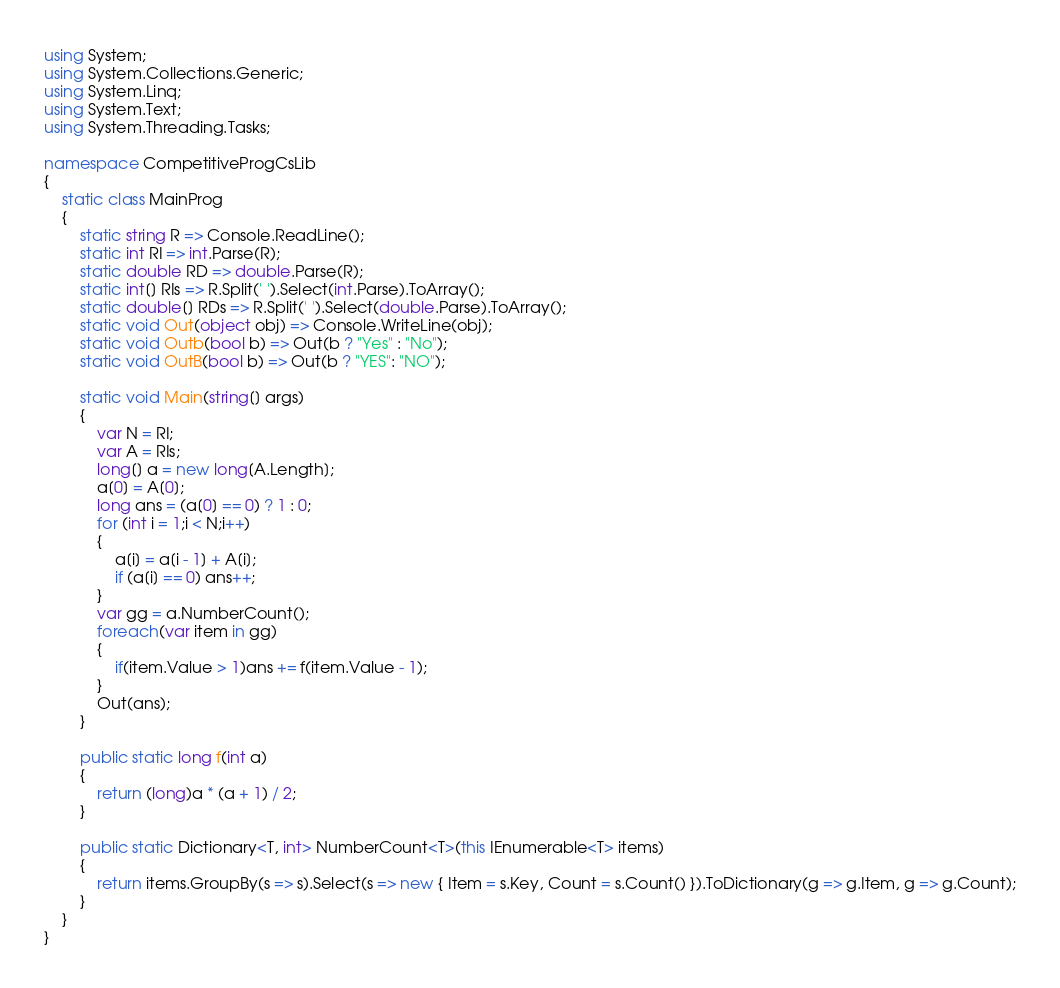<code> <loc_0><loc_0><loc_500><loc_500><_C#_>using System;
using System.Collections.Generic;
using System.Linq;
using System.Text;
using System.Threading.Tasks;

namespace CompetitiveProgCsLib
{
	static class MainProg
	{
		static string R => Console.ReadLine();
		static int RI => int.Parse(R);
		static double RD => double.Parse(R);
		static int[] RIs => R.Split(' ').Select(int.Parse).ToArray();
		static double[] RDs => R.Split(' ').Select(double.Parse).ToArray();
		static void Out(object obj) => Console.WriteLine(obj);
		static void Outb(bool b) => Out(b ? "Yes" : "No");
		static void OutB(bool b) => Out(b ? "YES": "NO");

		static void Main(string[] args)
		{
			var N = RI;
			var A = RIs;
			long[] a = new long[A.Length];
			a[0] = A[0];
			long ans = (a[0] == 0) ? 1 : 0;
			for (int i = 1;i < N;i++)
			{
				a[i] = a[i - 1] + A[i];
				if (a[i] == 0) ans++;
			}
			var gg = a.NumberCount();
			foreach(var item in gg)
			{
				if(item.Value > 1)ans += f(item.Value - 1);
			}
			Out(ans);
		}

		public static long f(int a)
		{
			return (long)a * (a + 1) / 2;
		}

		public static Dictionary<T, int> NumberCount<T>(this IEnumerable<T> items)
		{
			return items.GroupBy(s => s).Select(s => new { Item = s.Key, Count = s.Count() }).ToDictionary(g => g.Item, g => g.Count);
		}
	}
}
</code> 